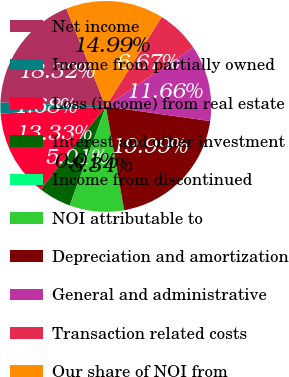Convert chart to OTSL. <chart><loc_0><loc_0><loc_500><loc_500><pie_chart><fcel>Net income<fcel>Income from partially owned<fcel>Loss (income) from real estate<fcel>Interest and other investment<fcel>Income from discontinued<fcel>NOI attributable to<fcel>Depreciation and amortization<fcel>General and administrative<fcel>Transaction related costs<fcel>Our share of NOI from<nl><fcel>18.32%<fcel>1.68%<fcel>13.33%<fcel>5.01%<fcel>0.01%<fcel>8.34%<fcel>19.99%<fcel>11.66%<fcel>6.67%<fcel>14.99%<nl></chart> 